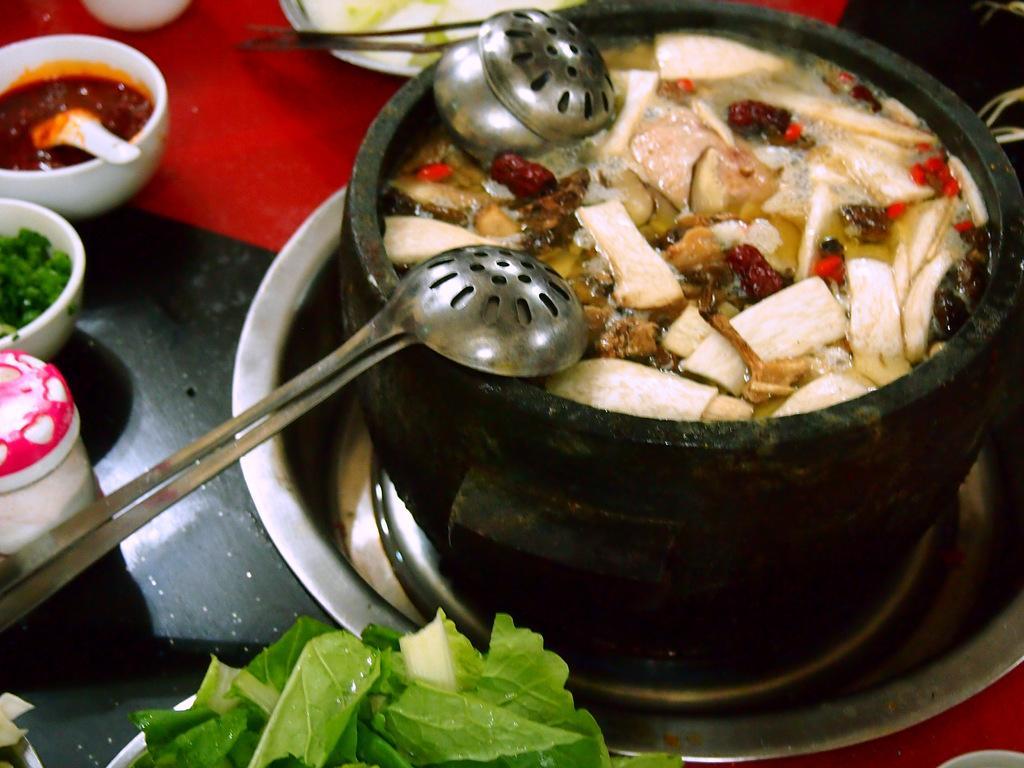Please provide a concise description of this image. In this picture, we see a bowl containing the spoons, water and the food item is placed in a vessel. At the bottom, we see a bowl containing the leafy vegetables. On the left side, we see a box in white and pink color. Beside that, we see the bowls containing a spoon and the food items are placed on a black and red color table. At the top, we see a white plate. 